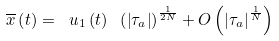Convert formula to latex. <formula><loc_0><loc_0><loc_500><loc_500>\overline { x } \left ( t \right ) = \ u _ { 1 } \left ( t \right ) \ \left ( \left | \tau _ { a } \right | \right ) ^ { \frac { 1 } { 2 N } } + O \left ( \left | \tau _ { a } \right | ^ { \frac { 1 } { N } } \right )</formula> 